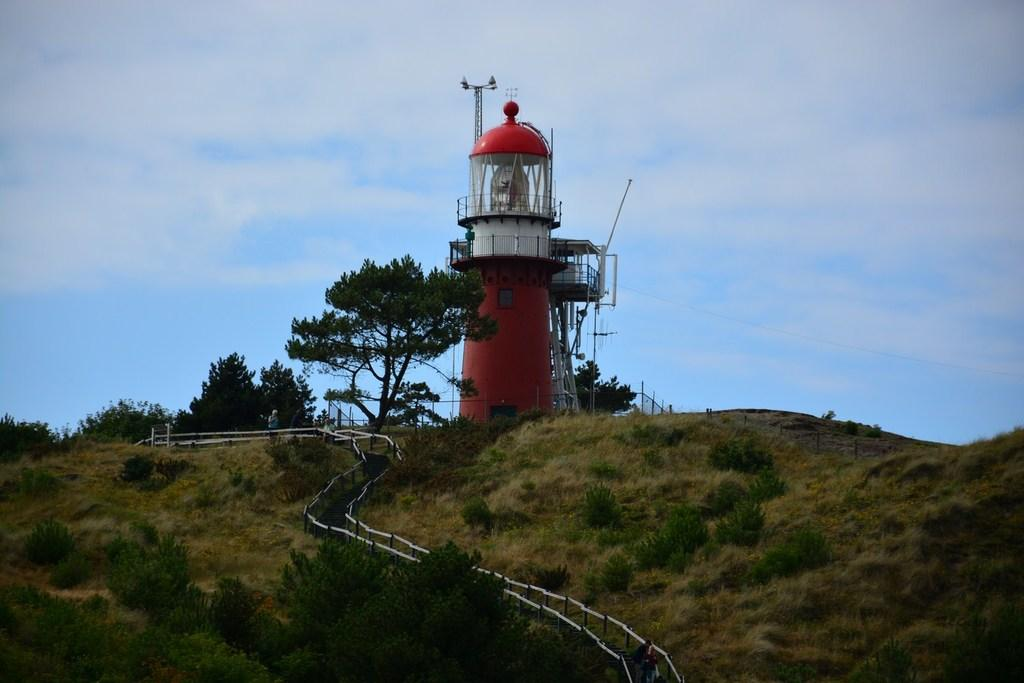What is the main structure in the picture? There is a lighthouse in the picture. What can be seen in front of the lighthouse? There are trees and a path in front of the lighthouse. What is visible behind the lighthouse? The sky is visible behind the lighthouse. How many chairs are placed around the lighthouse in the image? There are no chairs present in the image. What type of crow can be seen perched on the lighthouse in the image? There are no crows present in the image. 